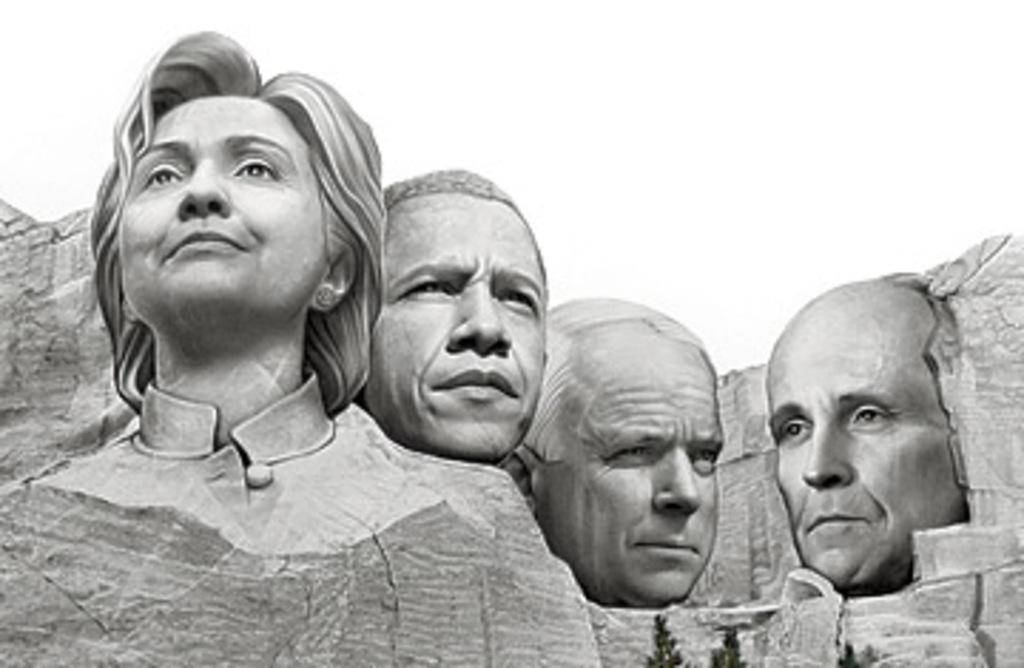Could you give a brief overview of what you see in this image? In the image on the rock there are statues of a lady and three men. 